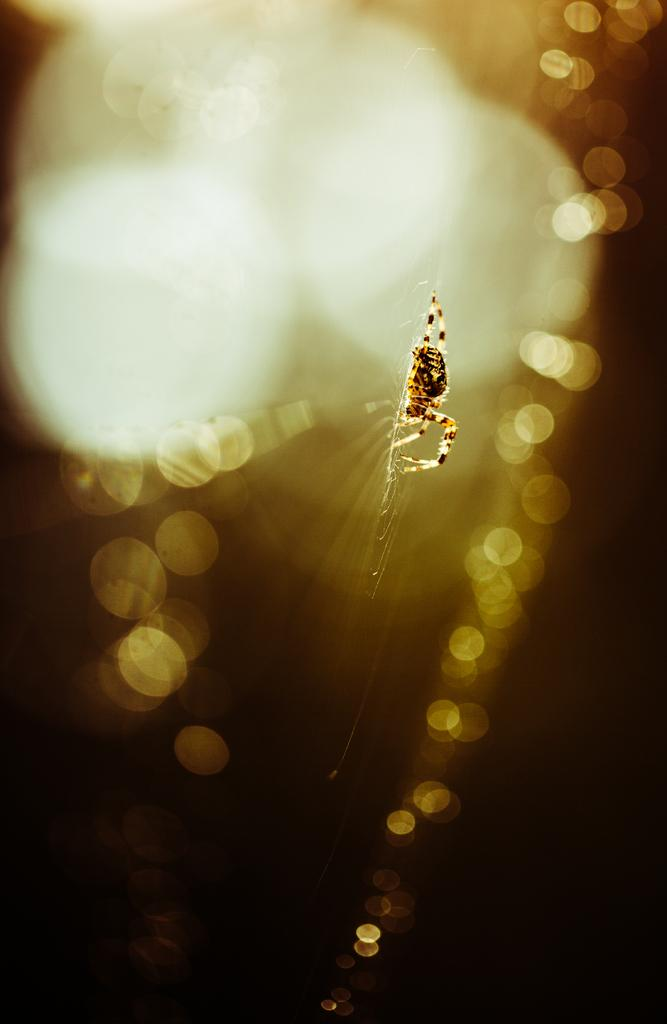What is the main subject of the image? The main subject of the image is a spider. Does the spider have any specific features or characteristics? Yes, the spider has a web. Can you describe the background of the image? The background of the image is blurred. What type of comb is being used by the spider in the image? There is no comb present in the image, as it features a spider with a web. Is there a chair visible in the image? No, there is no chair present in the image. 